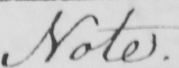What is written in this line of handwriting? Note . 